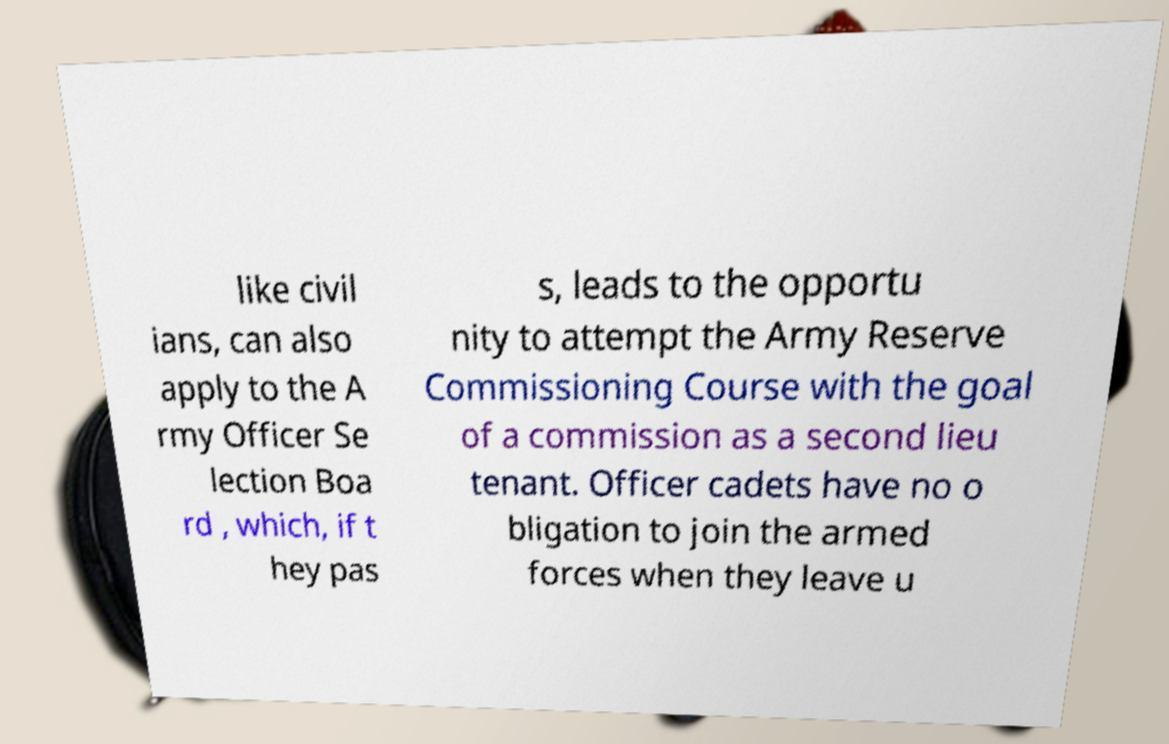Can you read and provide the text displayed in the image?This photo seems to have some interesting text. Can you extract and type it out for me? like civil ians, can also apply to the A rmy Officer Se lection Boa rd , which, if t hey pas s, leads to the opportu nity to attempt the Army Reserve Commissioning Course with the goal of a commission as a second lieu tenant. Officer cadets have no o bligation to join the armed forces when they leave u 